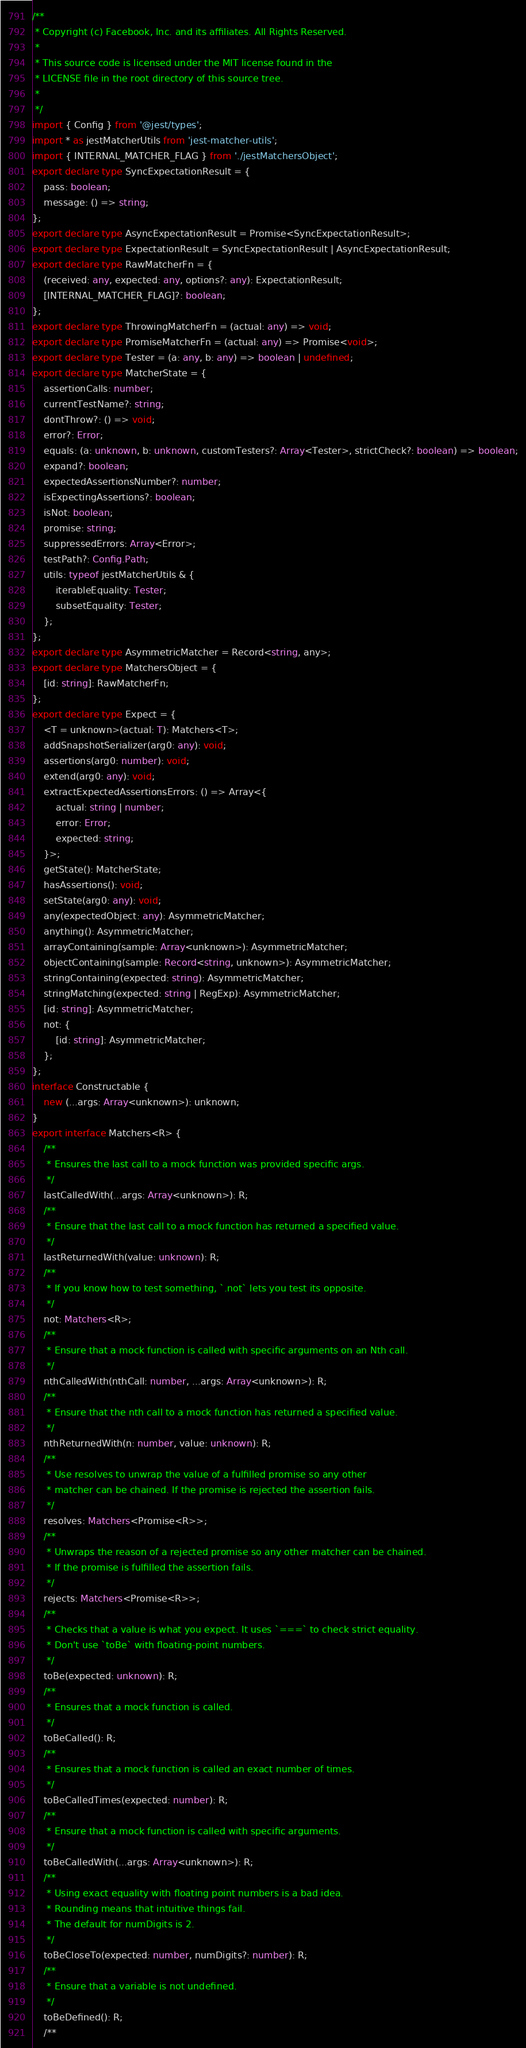Convert code to text. <code><loc_0><loc_0><loc_500><loc_500><_TypeScript_>/**
 * Copyright (c) Facebook, Inc. and its affiliates. All Rights Reserved.
 *
 * This source code is licensed under the MIT license found in the
 * LICENSE file in the root directory of this source tree.
 *
 */
import { Config } from '@jest/types';
import * as jestMatcherUtils from 'jest-matcher-utils';
import { INTERNAL_MATCHER_FLAG } from './jestMatchersObject';
export declare type SyncExpectationResult = {
    pass: boolean;
    message: () => string;
};
export declare type AsyncExpectationResult = Promise<SyncExpectationResult>;
export declare type ExpectationResult = SyncExpectationResult | AsyncExpectationResult;
export declare type RawMatcherFn = {
    (received: any, expected: any, options?: any): ExpectationResult;
    [INTERNAL_MATCHER_FLAG]?: boolean;
};
export declare type ThrowingMatcherFn = (actual: any) => void;
export declare type PromiseMatcherFn = (actual: any) => Promise<void>;
export declare type Tester = (a: any, b: any) => boolean | undefined;
export declare type MatcherState = {
    assertionCalls: number;
    currentTestName?: string;
    dontThrow?: () => void;
    error?: Error;
    equals: (a: unknown, b: unknown, customTesters?: Array<Tester>, strictCheck?: boolean) => boolean;
    expand?: boolean;
    expectedAssertionsNumber?: number;
    isExpectingAssertions?: boolean;
    isNot: boolean;
    promise: string;
    suppressedErrors: Array<Error>;
    testPath?: Config.Path;
    utils: typeof jestMatcherUtils & {
        iterableEquality: Tester;
        subsetEquality: Tester;
    };
};
export declare type AsymmetricMatcher = Record<string, any>;
export declare type MatchersObject = {
    [id: string]: RawMatcherFn;
};
export declare type Expect = {
    <T = unknown>(actual: T): Matchers<T>;
    addSnapshotSerializer(arg0: any): void;
    assertions(arg0: number): void;
    extend(arg0: any): void;
    extractExpectedAssertionsErrors: () => Array<{
        actual: string | number;
        error: Error;
        expected: string;
    }>;
    getState(): MatcherState;
    hasAssertions(): void;
    setState(arg0: any): void;
    any(expectedObject: any): AsymmetricMatcher;
    anything(): AsymmetricMatcher;
    arrayContaining(sample: Array<unknown>): AsymmetricMatcher;
    objectContaining(sample: Record<string, unknown>): AsymmetricMatcher;
    stringContaining(expected: string): AsymmetricMatcher;
    stringMatching(expected: string | RegExp): AsymmetricMatcher;
    [id: string]: AsymmetricMatcher;
    not: {
        [id: string]: AsymmetricMatcher;
    };
};
interface Constructable {
    new (...args: Array<unknown>): unknown;
}
export interface Matchers<R> {
    /**
     * Ensures the last call to a mock function was provided specific args.
     */
    lastCalledWith(...args: Array<unknown>): R;
    /**
     * Ensure that the last call to a mock function has returned a specified value.
     */
    lastReturnedWith(value: unknown): R;
    /**
     * If you know how to test something, `.not` lets you test its opposite.
     */
    not: Matchers<R>;
    /**
     * Ensure that a mock function is called with specific arguments on an Nth call.
     */
    nthCalledWith(nthCall: number, ...args: Array<unknown>): R;
    /**
     * Ensure that the nth call to a mock function has returned a specified value.
     */
    nthReturnedWith(n: number, value: unknown): R;
    /**
     * Use resolves to unwrap the value of a fulfilled promise so any other
     * matcher can be chained. If the promise is rejected the assertion fails.
     */
    resolves: Matchers<Promise<R>>;
    /**
     * Unwraps the reason of a rejected promise so any other matcher can be chained.
     * If the promise is fulfilled the assertion fails.
     */
    rejects: Matchers<Promise<R>>;
    /**
     * Checks that a value is what you expect. It uses `===` to check strict equality.
     * Don't use `toBe` with floating-point numbers.
     */
    toBe(expected: unknown): R;
    /**
     * Ensures that a mock function is called.
     */
    toBeCalled(): R;
    /**
     * Ensures that a mock function is called an exact number of times.
     */
    toBeCalledTimes(expected: number): R;
    /**
     * Ensure that a mock function is called with specific arguments.
     */
    toBeCalledWith(...args: Array<unknown>): R;
    /**
     * Using exact equality with floating point numbers is a bad idea.
     * Rounding means that intuitive things fail.
     * The default for numDigits is 2.
     */
    toBeCloseTo(expected: number, numDigits?: number): R;
    /**
     * Ensure that a variable is not undefined.
     */
    toBeDefined(): R;
    /**</code> 